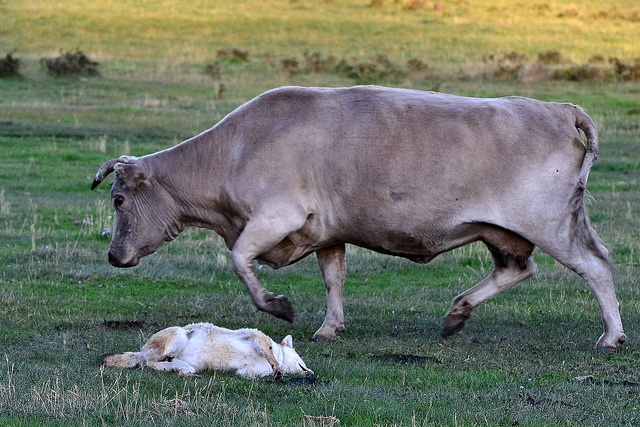Describe the objects in this image and their specific colors. I can see cow in olive, gray, and black tones and dog in olive, lavender, darkgray, and gray tones in this image. 